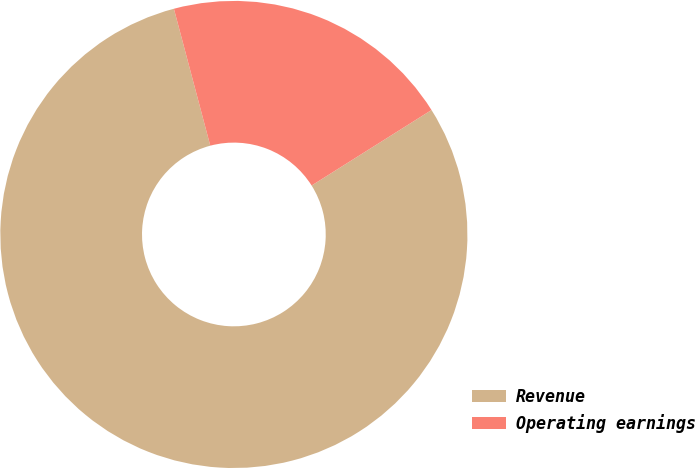Convert chart to OTSL. <chart><loc_0><loc_0><loc_500><loc_500><pie_chart><fcel>Revenue<fcel>Operating earnings<nl><fcel>79.81%<fcel>20.19%<nl></chart> 